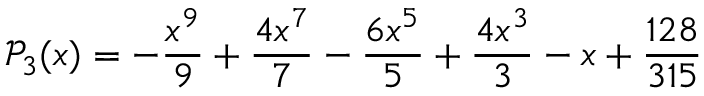Convert formula to latex. <formula><loc_0><loc_0><loc_500><loc_500>\mathcal { P } _ { 3 } ( x ) = - \frac { x ^ { 9 } } { 9 } + \frac { 4 x ^ { 7 } } { 7 } - \frac { 6 x ^ { 5 } } { 5 } + \frac { 4 x ^ { 3 } } { 3 } - x + \frac { 1 2 8 } { 3 1 5 }</formula> 